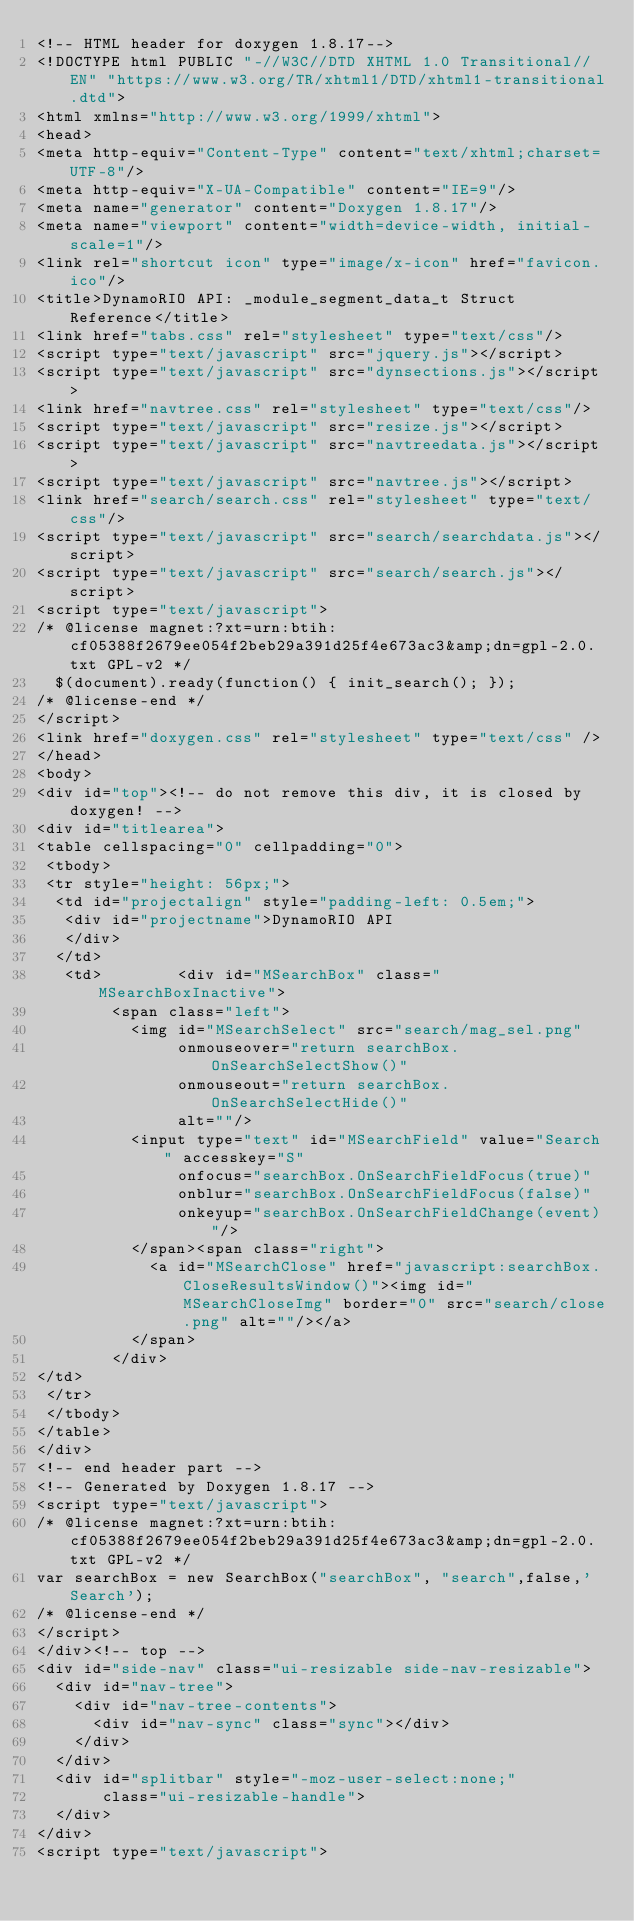<code> <loc_0><loc_0><loc_500><loc_500><_HTML_><!-- HTML header for doxygen 1.8.17-->
<!DOCTYPE html PUBLIC "-//W3C//DTD XHTML 1.0 Transitional//EN" "https://www.w3.org/TR/xhtml1/DTD/xhtml1-transitional.dtd">
<html xmlns="http://www.w3.org/1999/xhtml">
<head>
<meta http-equiv="Content-Type" content="text/xhtml;charset=UTF-8"/>
<meta http-equiv="X-UA-Compatible" content="IE=9"/>
<meta name="generator" content="Doxygen 1.8.17"/>
<meta name="viewport" content="width=device-width, initial-scale=1"/>
<link rel="shortcut icon" type="image/x-icon" href="favicon.ico"/>
<title>DynamoRIO API: _module_segment_data_t Struct Reference</title>
<link href="tabs.css" rel="stylesheet" type="text/css"/>
<script type="text/javascript" src="jquery.js"></script>
<script type="text/javascript" src="dynsections.js"></script>
<link href="navtree.css" rel="stylesheet" type="text/css"/>
<script type="text/javascript" src="resize.js"></script>
<script type="text/javascript" src="navtreedata.js"></script>
<script type="text/javascript" src="navtree.js"></script>
<link href="search/search.css" rel="stylesheet" type="text/css"/>
<script type="text/javascript" src="search/searchdata.js"></script>
<script type="text/javascript" src="search/search.js"></script>
<script type="text/javascript">
/* @license magnet:?xt=urn:btih:cf05388f2679ee054f2beb29a391d25f4e673ac3&amp;dn=gpl-2.0.txt GPL-v2 */
  $(document).ready(function() { init_search(); });
/* @license-end */
</script>
<link href="doxygen.css" rel="stylesheet" type="text/css" />
</head>
<body>
<div id="top"><!-- do not remove this div, it is closed by doxygen! -->
<div id="titlearea">
<table cellspacing="0" cellpadding="0">
 <tbody>
 <tr style="height: 56px;">
  <td id="projectalign" style="padding-left: 0.5em;">
   <div id="projectname">DynamoRIO API
   </div>
  </td>
   <td>        <div id="MSearchBox" class="MSearchBoxInactive">
        <span class="left">
          <img id="MSearchSelect" src="search/mag_sel.png"
               onmouseover="return searchBox.OnSearchSelectShow()"
               onmouseout="return searchBox.OnSearchSelectHide()"
               alt=""/>
          <input type="text" id="MSearchField" value="Search" accesskey="S"
               onfocus="searchBox.OnSearchFieldFocus(true)" 
               onblur="searchBox.OnSearchFieldFocus(false)" 
               onkeyup="searchBox.OnSearchFieldChange(event)"/>
          </span><span class="right">
            <a id="MSearchClose" href="javascript:searchBox.CloseResultsWindow()"><img id="MSearchCloseImg" border="0" src="search/close.png" alt=""/></a>
          </span>
        </div>
</td>
 </tr>
 </tbody>
</table>
</div>
<!-- end header part -->
<!-- Generated by Doxygen 1.8.17 -->
<script type="text/javascript">
/* @license magnet:?xt=urn:btih:cf05388f2679ee054f2beb29a391d25f4e673ac3&amp;dn=gpl-2.0.txt GPL-v2 */
var searchBox = new SearchBox("searchBox", "search",false,'Search');
/* @license-end */
</script>
</div><!-- top -->
<div id="side-nav" class="ui-resizable side-nav-resizable">
  <div id="nav-tree">
    <div id="nav-tree-contents">
      <div id="nav-sync" class="sync"></div>
    </div>
  </div>
  <div id="splitbar" style="-moz-user-select:none;" 
       class="ui-resizable-handle">
  </div>
</div>
<script type="text/javascript"></code> 